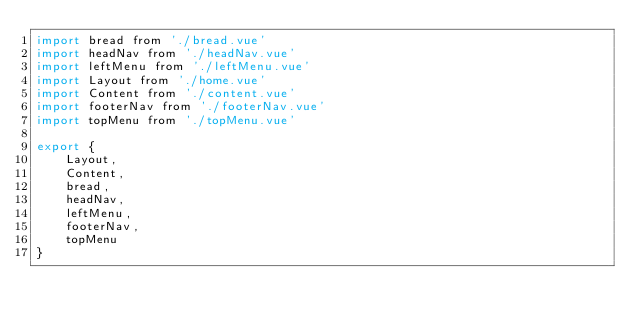<code> <loc_0><loc_0><loc_500><loc_500><_JavaScript_>import bread from './bread.vue'
import headNav from './headNav.vue'
import leftMenu from './leftMenu.vue'
import Layout from './home.vue'
import Content from './content.vue'
import footerNav from './footerNav.vue'
import topMenu from './topMenu.vue'

export {
    Layout,
    Content,
    bread,
    headNav,
    leftMenu,
    footerNav,
    topMenu
}
</code> 